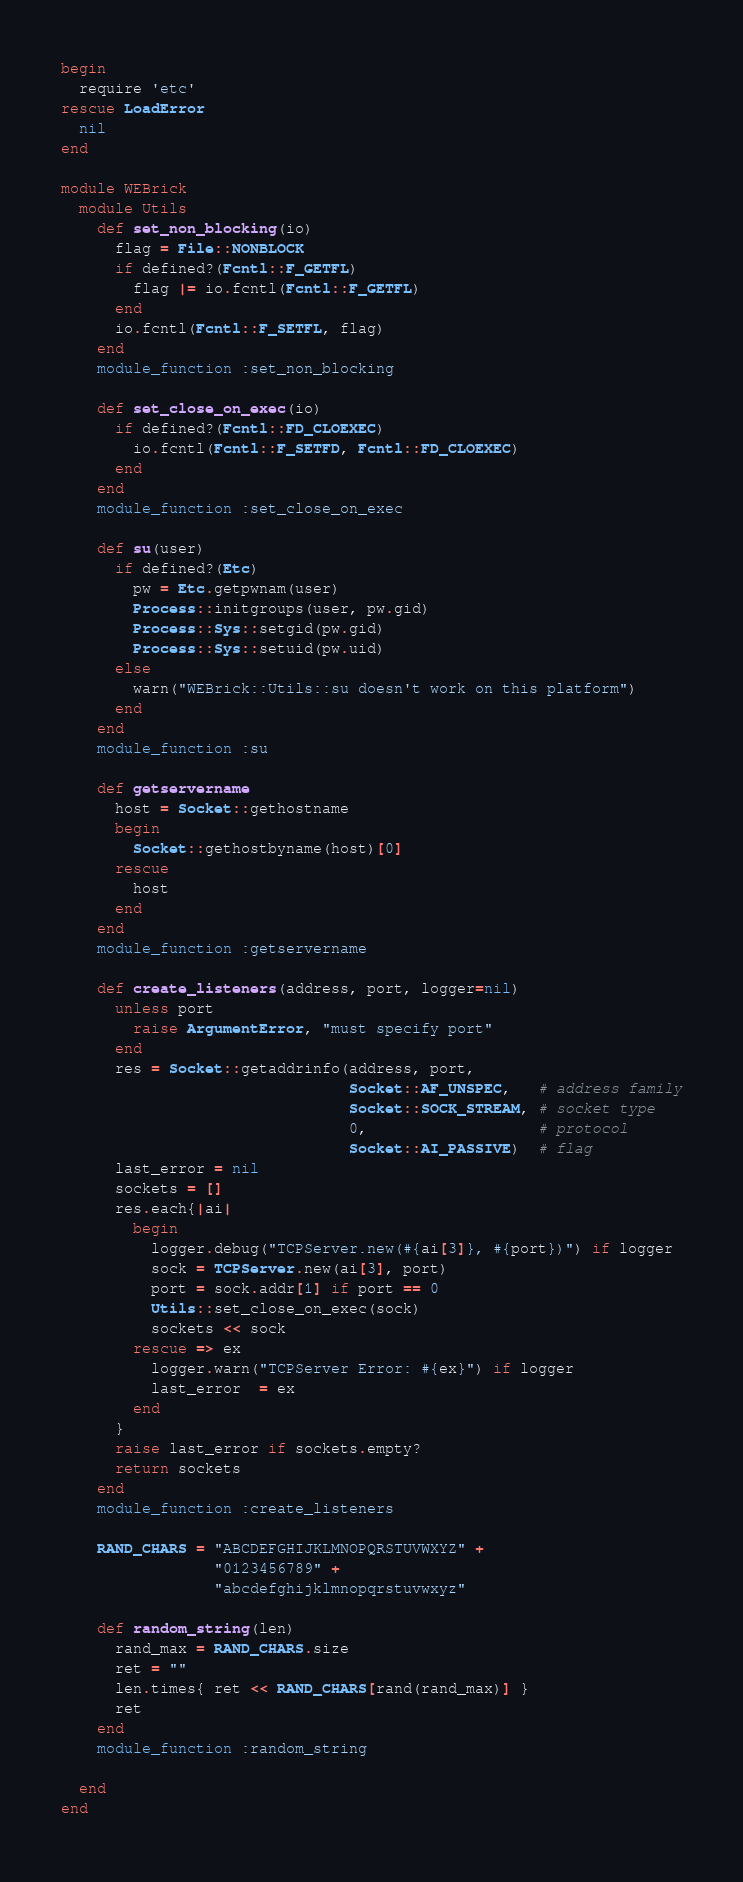Convert code to text. <code><loc_0><loc_0><loc_500><loc_500><_Ruby_>begin
  require 'etc'
rescue LoadError
  nil
end

module WEBrick
  module Utils
    def set_non_blocking(io)
      flag = File::NONBLOCK
      if defined?(Fcntl::F_GETFL)
        flag |= io.fcntl(Fcntl::F_GETFL)
      end
      io.fcntl(Fcntl::F_SETFL, flag)
    end
    module_function :set_non_blocking

    def set_close_on_exec(io)
      if defined?(Fcntl::FD_CLOEXEC)
        io.fcntl(Fcntl::F_SETFD, Fcntl::FD_CLOEXEC)
      end
    end
    module_function :set_close_on_exec

    def su(user)
      if defined?(Etc)
        pw = Etc.getpwnam(user)
        Process::initgroups(user, pw.gid)
        Process::Sys::setgid(pw.gid)
        Process::Sys::setuid(pw.uid)
      else
        warn("WEBrick::Utils::su doesn't work on this platform")
      end
    end
    module_function :su

    def getservername
      host = Socket::gethostname
      begin
        Socket::gethostbyname(host)[0]
      rescue
        host
      end
    end
    module_function :getservername

    def create_listeners(address, port, logger=nil)
      unless port
        raise ArgumentError, "must specify port"
      end
      res = Socket::getaddrinfo(address, port,
                                Socket::AF_UNSPEC,   # address family
                                Socket::SOCK_STREAM, # socket type
                                0,                   # protocol
                                Socket::AI_PASSIVE)  # flag
      last_error = nil
      sockets = []
      res.each{|ai|
        begin
          logger.debug("TCPServer.new(#{ai[3]}, #{port})") if logger
          sock = TCPServer.new(ai[3], port)
          port = sock.addr[1] if port == 0
          Utils::set_close_on_exec(sock)
          sockets << sock
        rescue => ex
          logger.warn("TCPServer Error: #{ex}") if logger
          last_error  = ex
        end
      }
      raise last_error if sockets.empty?
      return sockets
    end
    module_function :create_listeners

    RAND_CHARS = "ABCDEFGHIJKLMNOPQRSTUVWXYZ" +
                 "0123456789" +
                 "abcdefghijklmnopqrstuvwxyz" 

    def random_string(len)
      rand_max = RAND_CHARS.size
      ret = "" 
      len.times{ ret << RAND_CHARS[rand(rand_max)] }
      ret 
    end
    module_function :random_string

  end
end
</code> 